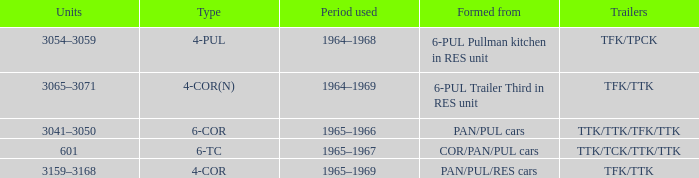Identify the third kind of 6-pul trailer formed in the res unit. 4-COR(N). 